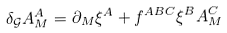Convert formula to latex. <formula><loc_0><loc_0><loc_500><loc_500>\delta _ { \mathcal { G } } A ^ { A } _ { M } = \partial _ { M } \xi ^ { A } + f ^ { A B C } \xi ^ { B } A ^ { C } _ { M }</formula> 